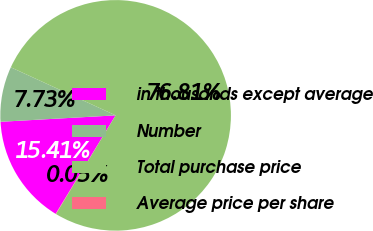Convert chart to OTSL. <chart><loc_0><loc_0><loc_500><loc_500><pie_chart><fcel>in thousands except average<fcel>Number<fcel>Total purchase price<fcel>Average price per share<nl><fcel>15.41%<fcel>7.73%<fcel>76.81%<fcel>0.05%<nl></chart> 